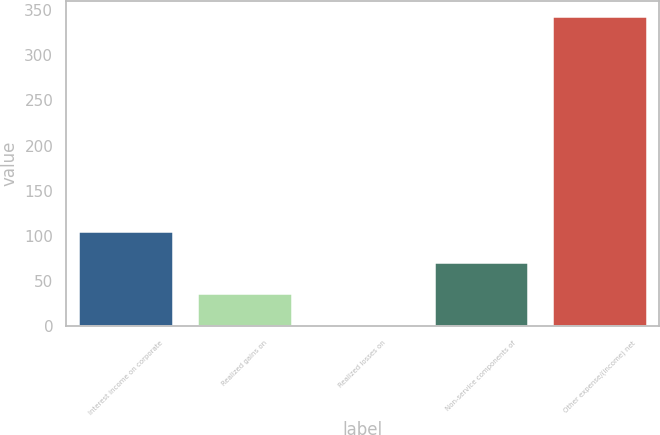Convert chart. <chart><loc_0><loc_0><loc_500><loc_500><bar_chart><fcel>Interest income on corporate<fcel>Realized gains on<fcel>Realized losses on<fcel>Non-service components of<fcel>Other expense/(income) net<nl><fcel>105.13<fcel>37.11<fcel>3.1<fcel>71.12<fcel>343.2<nl></chart> 